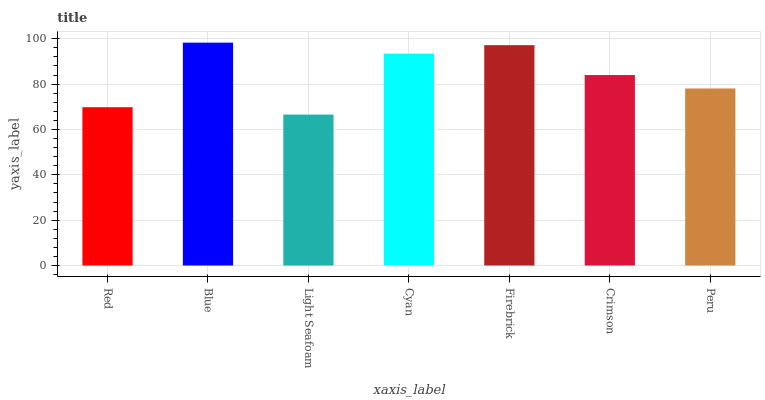Is Light Seafoam the minimum?
Answer yes or no. Yes. Is Blue the maximum?
Answer yes or no. Yes. Is Blue the minimum?
Answer yes or no. No. Is Light Seafoam the maximum?
Answer yes or no. No. Is Blue greater than Light Seafoam?
Answer yes or no. Yes. Is Light Seafoam less than Blue?
Answer yes or no. Yes. Is Light Seafoam greater than Blue?
Answer yes or no. No. Is Blue less than Light Seafoam?
Answer yes or no. No. Is Crimson the high median?
Answer yes or no. Yes. Is Crimson the low median?
Answer yes or no. Yes. Is Cyan the high median?
Answer yes or no. No. Is Blue the low median?
Answer yes or no. No. 